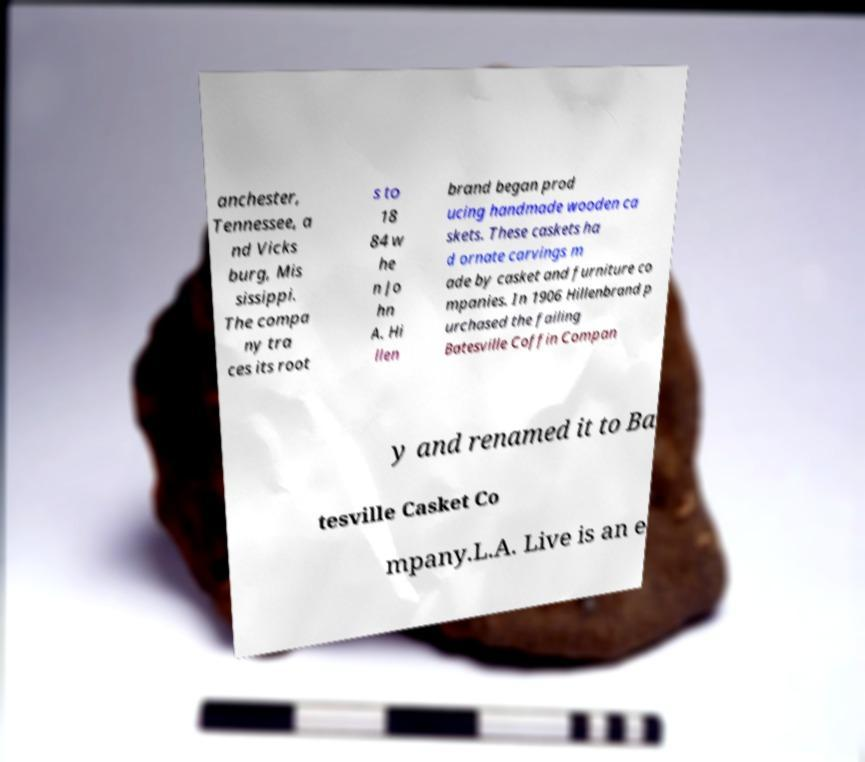Could you assist in decoding the text presented in this image and type it out clearly? anchester, Tennessee, a nd Vicks burg, Mis sissippi. The compa ny tra ces its root s to 18 84 w he n Jo hn A. Hi llen brand began prod ucing handmade wooden ca skets. These caskets ha d ornate carvings m ade by casket and furniture co mpanies. In 1906 Hillenbrand p urchased the failing Batesville Coffin Compan y and renamed it to Ba tesville Casket Co mpany.L.A. Live is an e 